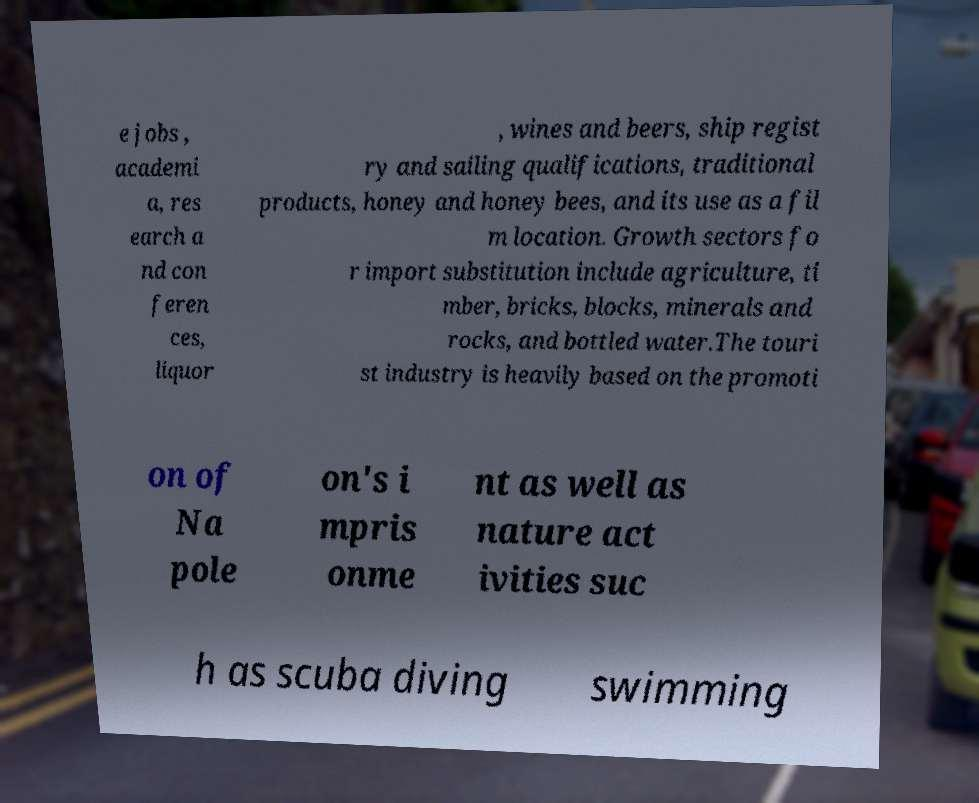Could you extract and type out the text from this image? e jobs , academi a, res earch a nd con feren ces, liquor , wines and beers, ship regist ry and sailing qualifications, traditional products, honey and honey bees, and its use as a fil m location. Growth sectors fo r import substitution include agriculture, ti mber, bricks, blocks, minerals and rocks, and bottled water.The touri st industry is heavily based on the promoti on of Na pole on's i mpris onme nt as well as nature act ivities suc h as scuba diving swimming 